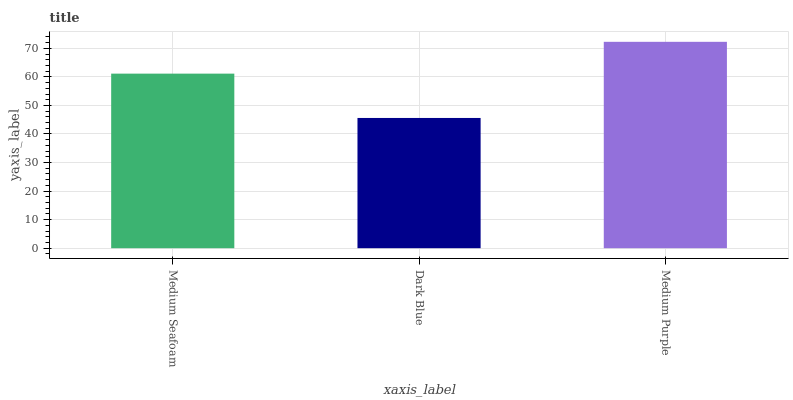Is Dark Blue the minimum?
Answer yes or no. Yes. Is Medium Purple the maximum?
Answer yes or no. Yes. Is Medium Purple the minimum?
Answer yes or no. No. Is Dark Blue the maximum?
Answer yes or no. No. Is Medium Purple greater than Dark Blue?
Answer yes or no. Yes. Is Dark Blue less than Medium Purple?
Answer yes or no. Yes. Is Dark Blue greater than Medium Purple?
Answer yes or no. No. Is Medium Purple less than Dark Blue?
Answer yes or no. No. Is Medium Seafoam the high median?
Answer yes or no. Yes. Is Medium Seafoam the low median?
Answer yes or no. Yes. Is Medium Purple the high median?
Answer yes or no. No. Is Medium Purple the low median?
Answer yes or no. No. 